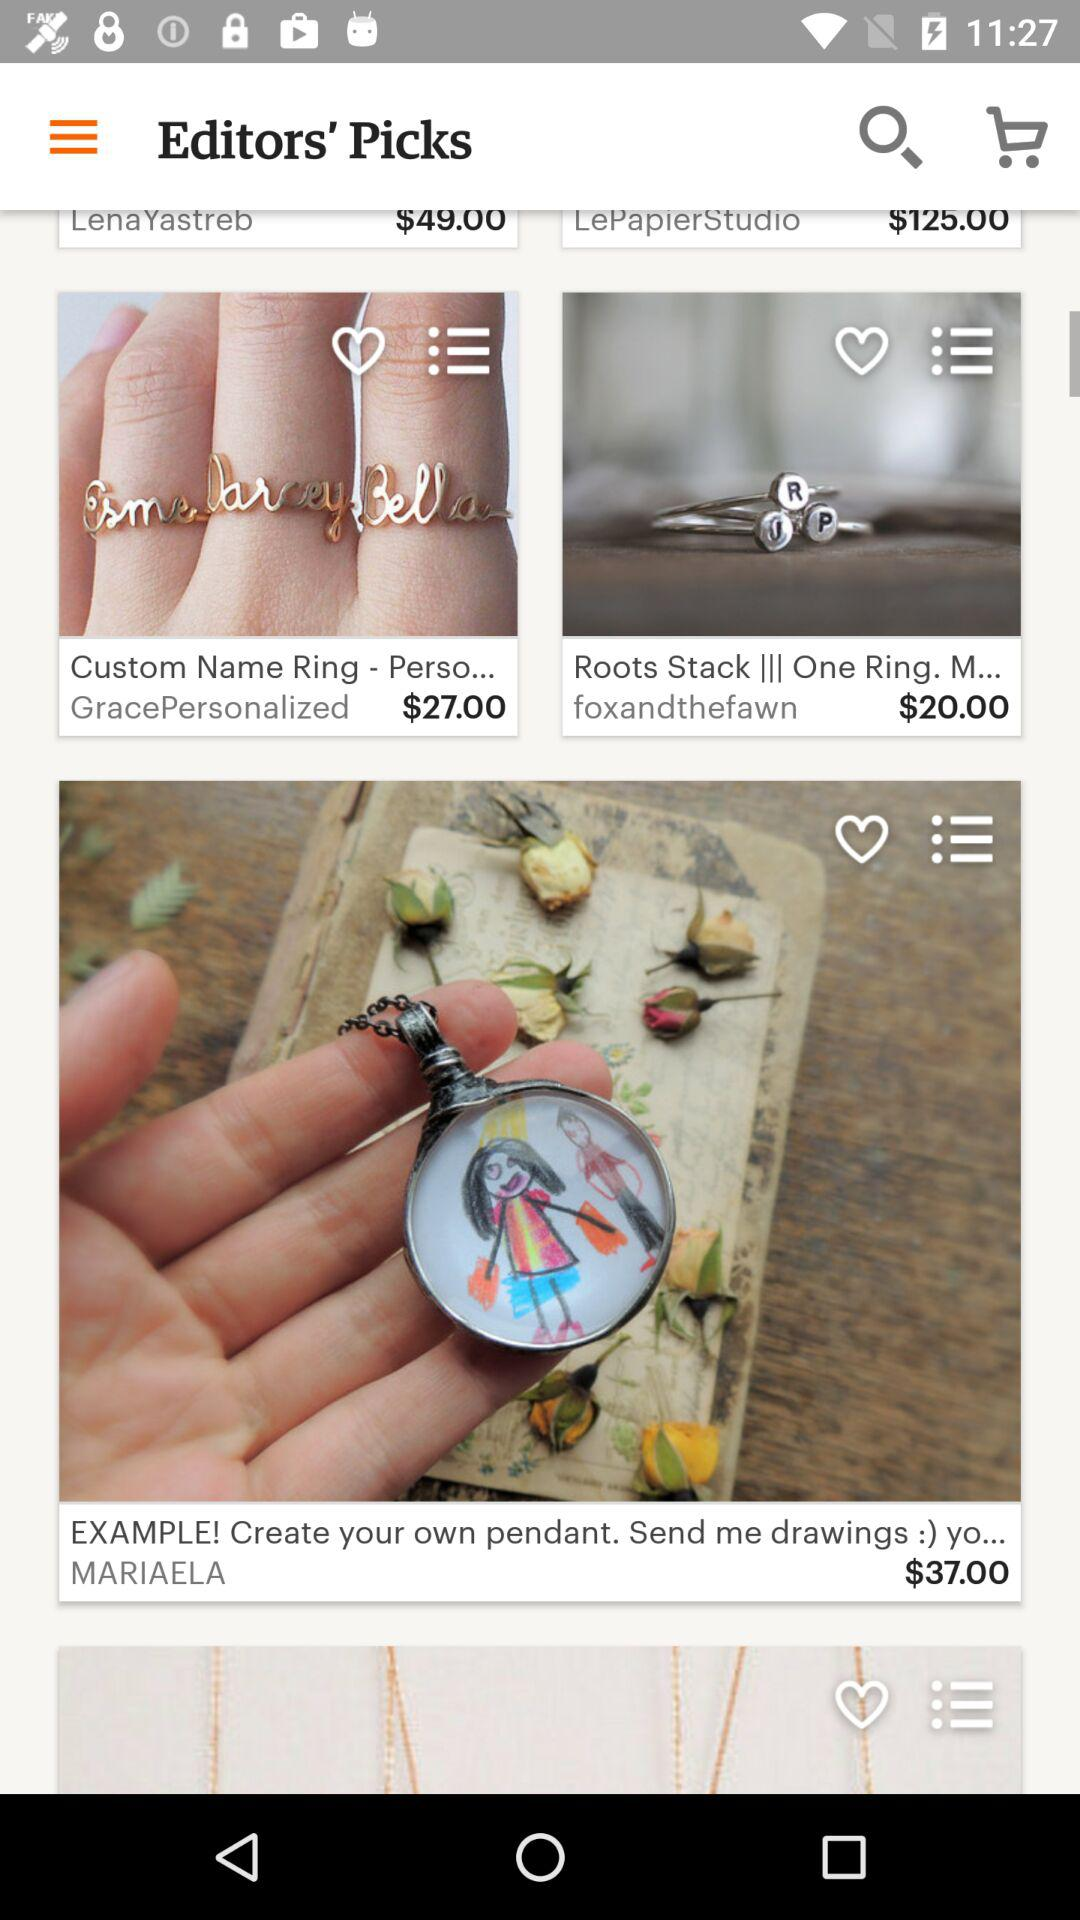How much do I have to pay to buy one Roots Stack ring? You have to pay $20.00 to buy one Roots Stack ring. 